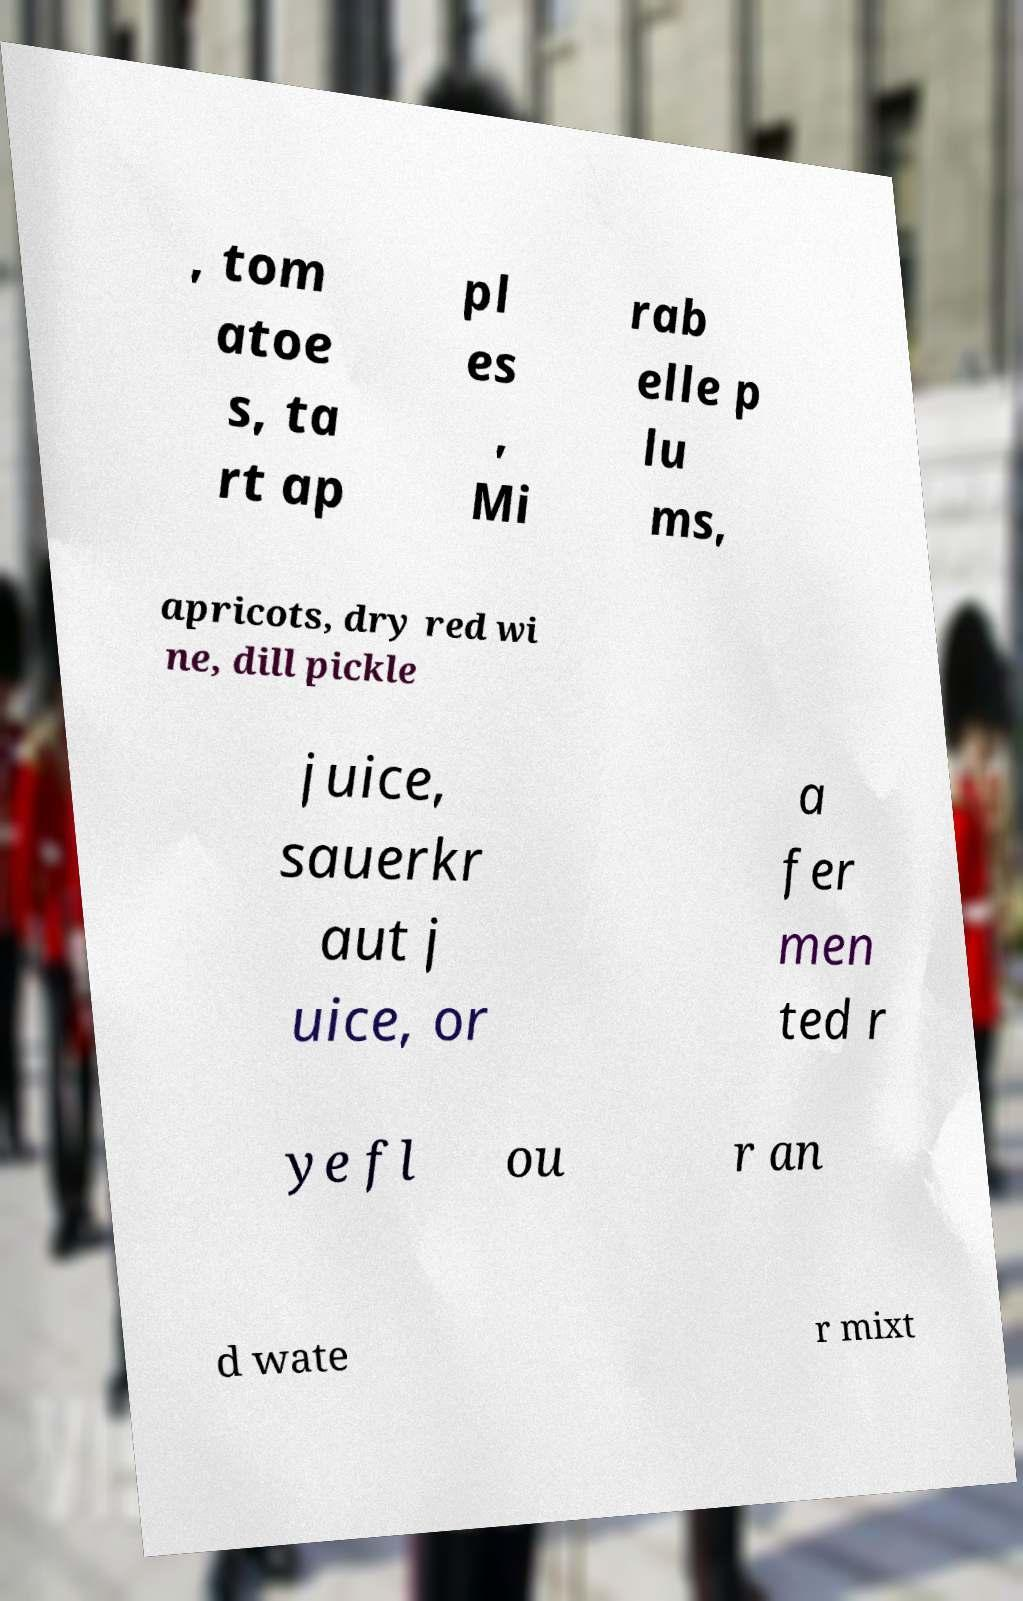For documentation purposes, I need the text within this image transcribed. Could you provide that? , tom atoe s, ta rt ap pl es , Mi rab elle p lu ms, apricots, dry red wi ne, dill pickle juice, sauerkr aut j uice, or a fer men ted r ye fl ou r an d wate r mixt 